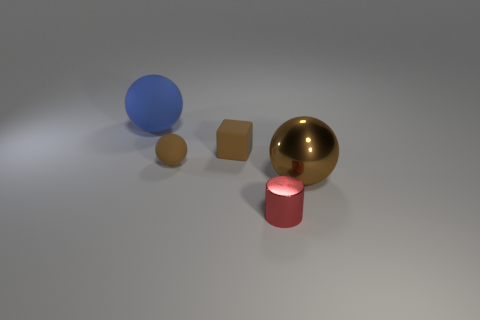Subtract all brown spheres. How many were subtracted if there are1brown spheres left? 1 Subtract all small balls. How many balls are left? 2 Subtract all spheres. How many objects are left? 2 Subtract all blue balls. How many balls are left? 2 Subtract 0 brown cylinders. How many objects are left? 5 Subtract 1 blocks. How many blocks are left? 0 Subtract all green blocks. Subtract all red spheres. How many blocks are left? 1 Subtract all cyan balls. How many gray blocks are left? 0 Subtract all gray shiny cylinders. Subtract all small rubber things. How many objects are left? 3 Add 1 large rubber objects. How many large rubber objects are left? 2 